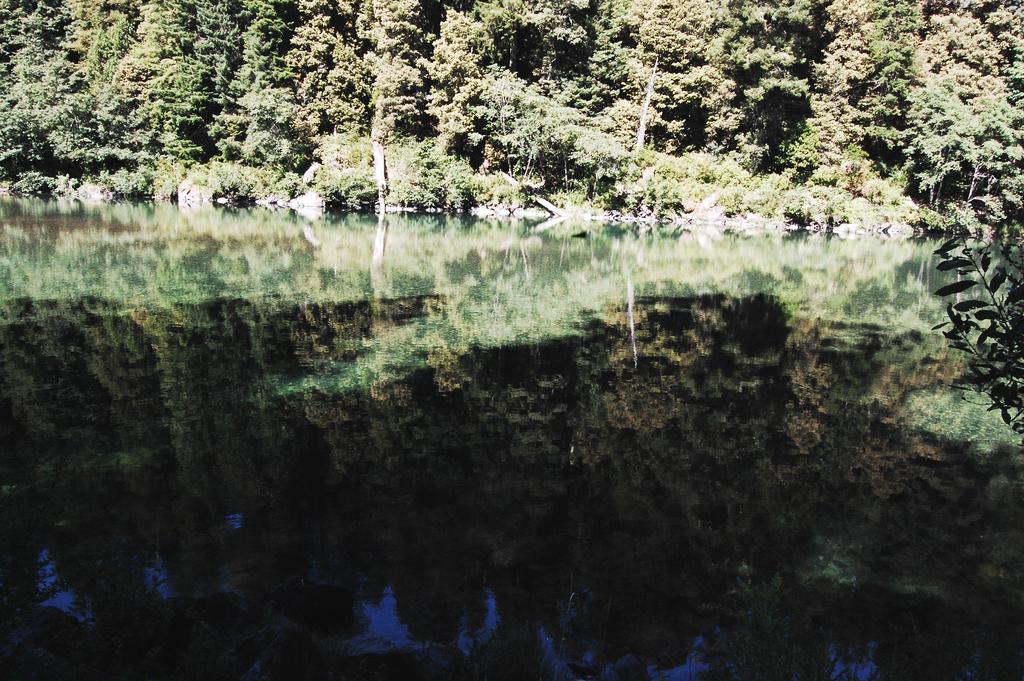In one or two sentences, can you explain what this image depicts? In this image there is a river towards the bottom of the image, there is a plant towards the right of the image, there are trees towards the top of the image. 